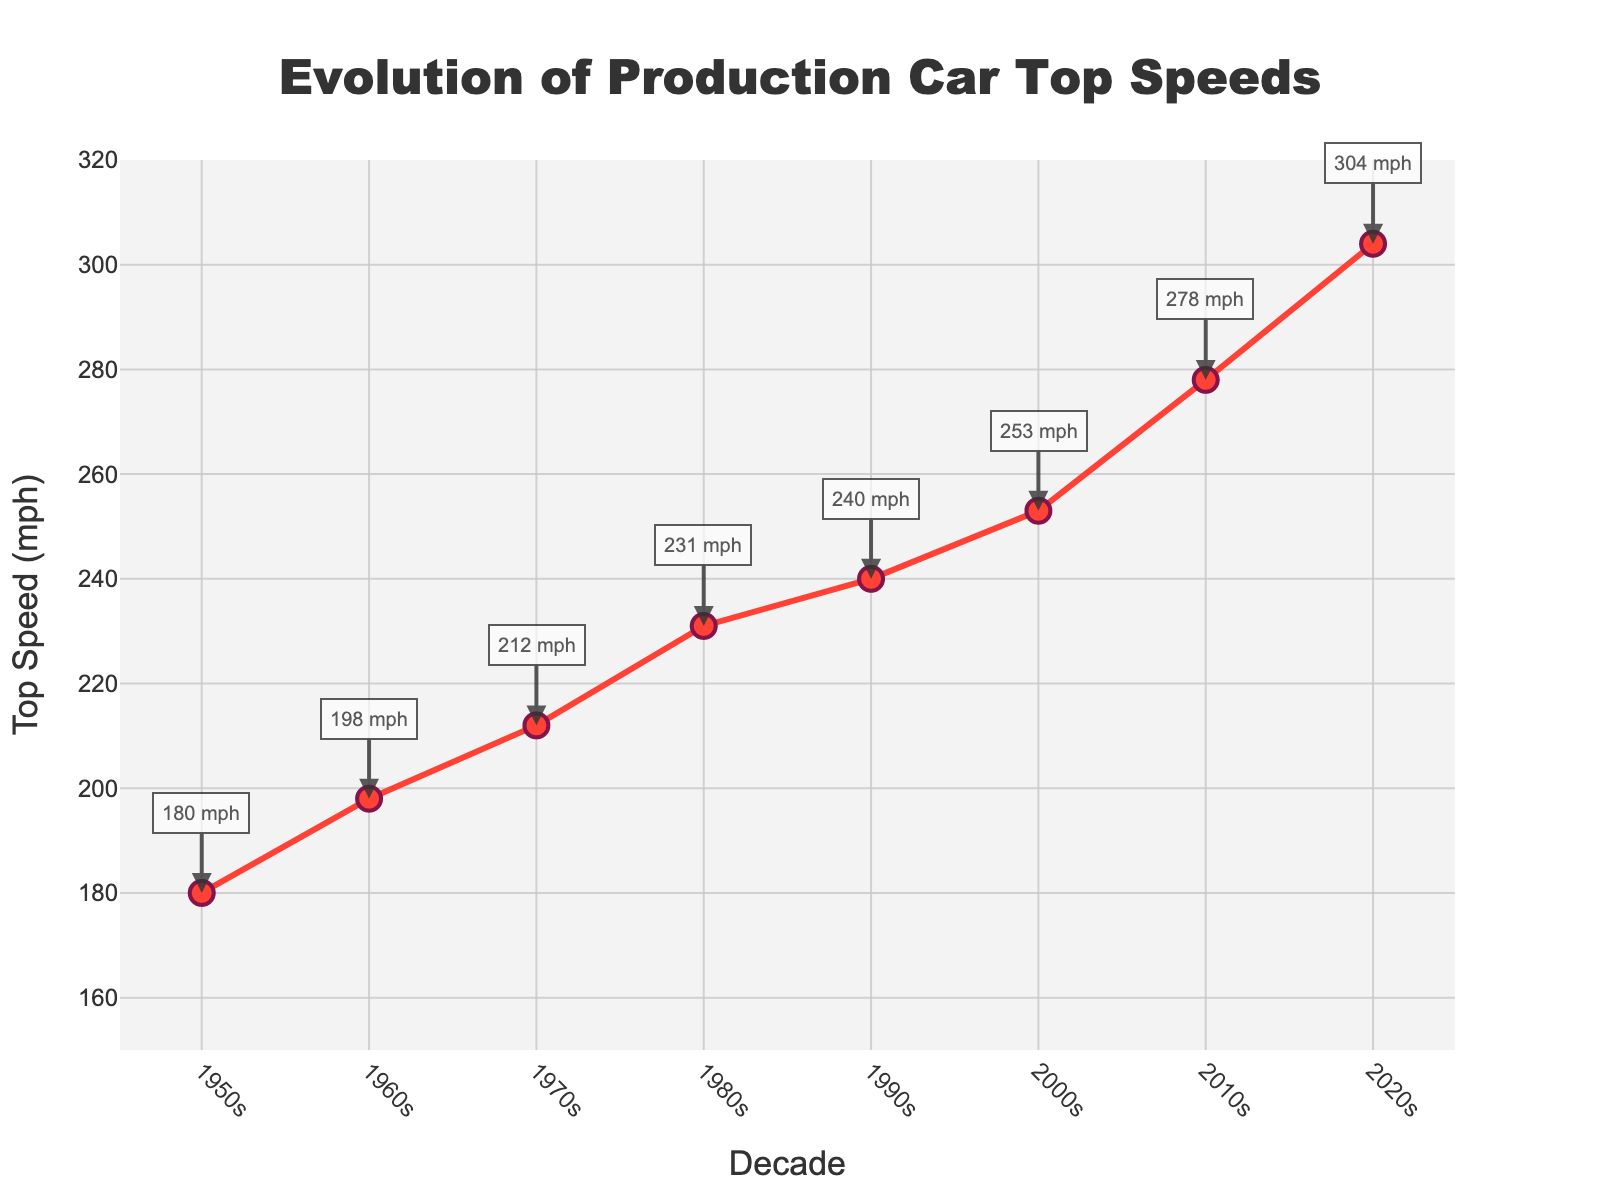What is the top speed for the 2010s decade? The value for the 2010s on the y-axis indicates a speed of 278 mph.
Answer: 278 mph Which decade saw the largest increase in top speed compared to the previous decade? Calculate the difference in top speed between each decade and the one before it. The largest increase (26 mph) occurs between the 2010s (278 mph) and 2020s (304 mph).
Answer: 2020s What is the average top speed recorded over these decades? Sum the top speeds: 180 + 198 + 212 + 231 + 240 + 253 + 278 + 304 = 1896. Divide by the number of decades (8). 1896 / 8 = 237 mph.
Answer: 237 mph Between which two consecutive decades was the smallest increase in top speed observed? Compute the increase for each consecutive decade: 1980s to 1990s is 240-231 = 9 mph, which is the smallest increase.
Answer: 1980s to 1990s What color is used for the line representing the top speeds? The red-colored line represents the top speeds, as observed visually.
Answer: Red By how much did the top speed increase from the 1950s to the 2000s? Subtract the top speed of the 1950s (180 mph) from the 2000s (253 mph): 253 - 180 = 73 mph.
Answer: 73 mph What is the speed value annotated for the 2020s decade? The annotation above the mark for the 2020s on the chart indicates 304 mph.
Answer: 304 mph Which decade had a top speed of 212 mph? The value 212 mph corresponds to the 1970s, as seen on the y-axis.
Answer: 1970s 